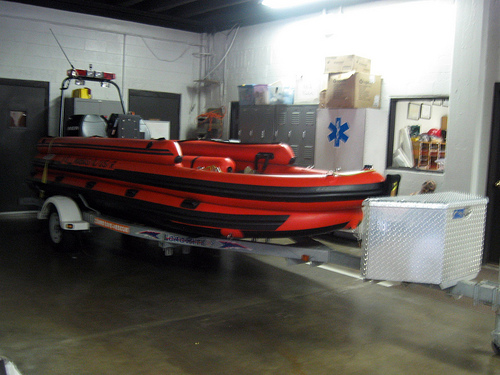<image>
Can you confirm if the boat is behind the wall? No. The boat is not behind the wall. From this viewpoint, the boat appears to be positioned elsewhere in the scene. 